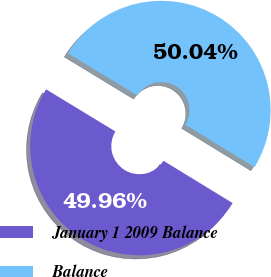Convert chart. <chart><loc_0><loc_0><loc_500><loc_500><pie_chart><fcel>January 1 2009 Balance<fcel>Balance<nl><fcel>49.96%<fcel>50.04%<nl></chart> 